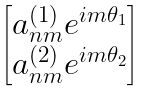<formula> <loc_0><loc_0><loc_500><loc_500>\begin{bmatrix} a _ { n m } ^ { ( 1 ) } e ^ { i m \theta _ { 1 } } \\ a _ { n m } ^ { ( 2 ) } e ^ { i m \theta _ { 2 } } \end{bmatrix}</formula> 